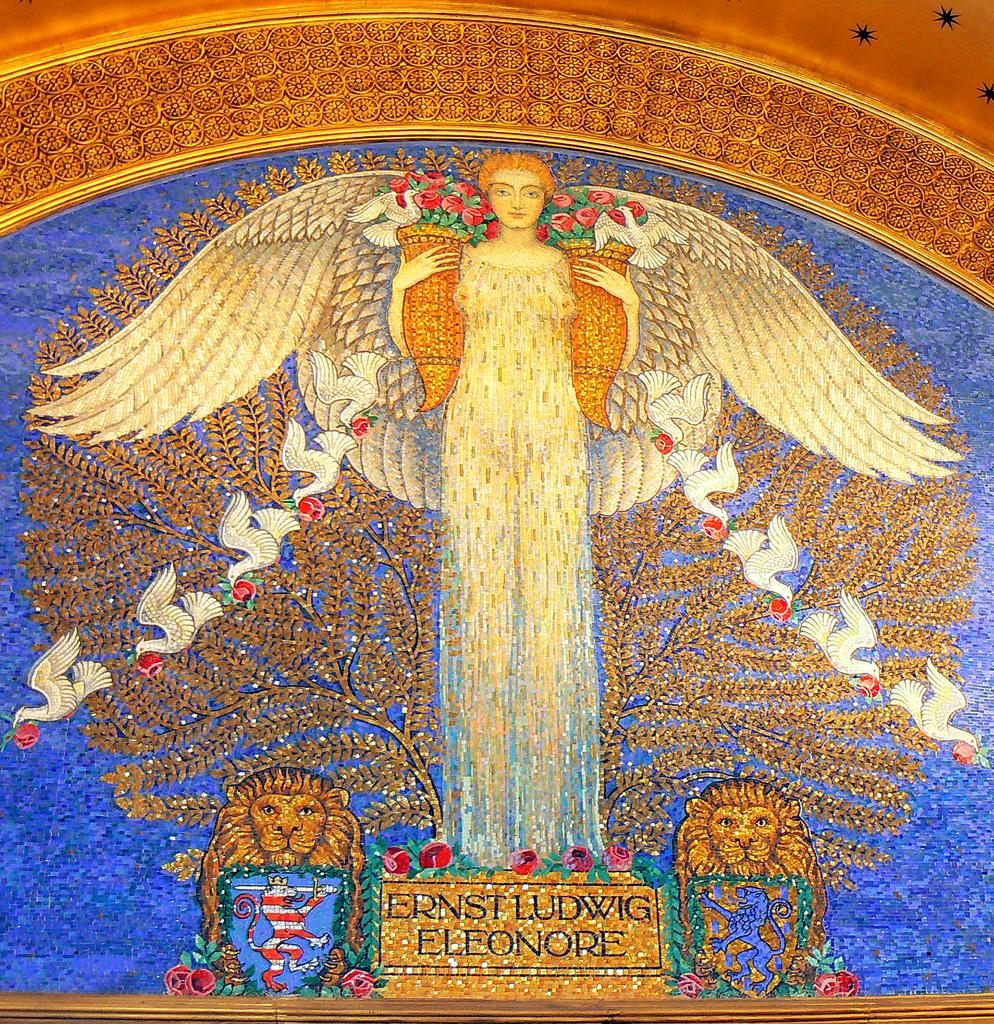What type of artwork is depicted in the image? The image is a painting. Who or what can be seen in the painting? There is a lady standing in the painting, along with animals, birds, and a tree. Are there any words or letters in the painting? Yes, there is text in the painting. What type of floor can be seen in the painting? There is no floor visible in the painting, as it is a painting of a scene with a lady, animals, birds, and a tree. 